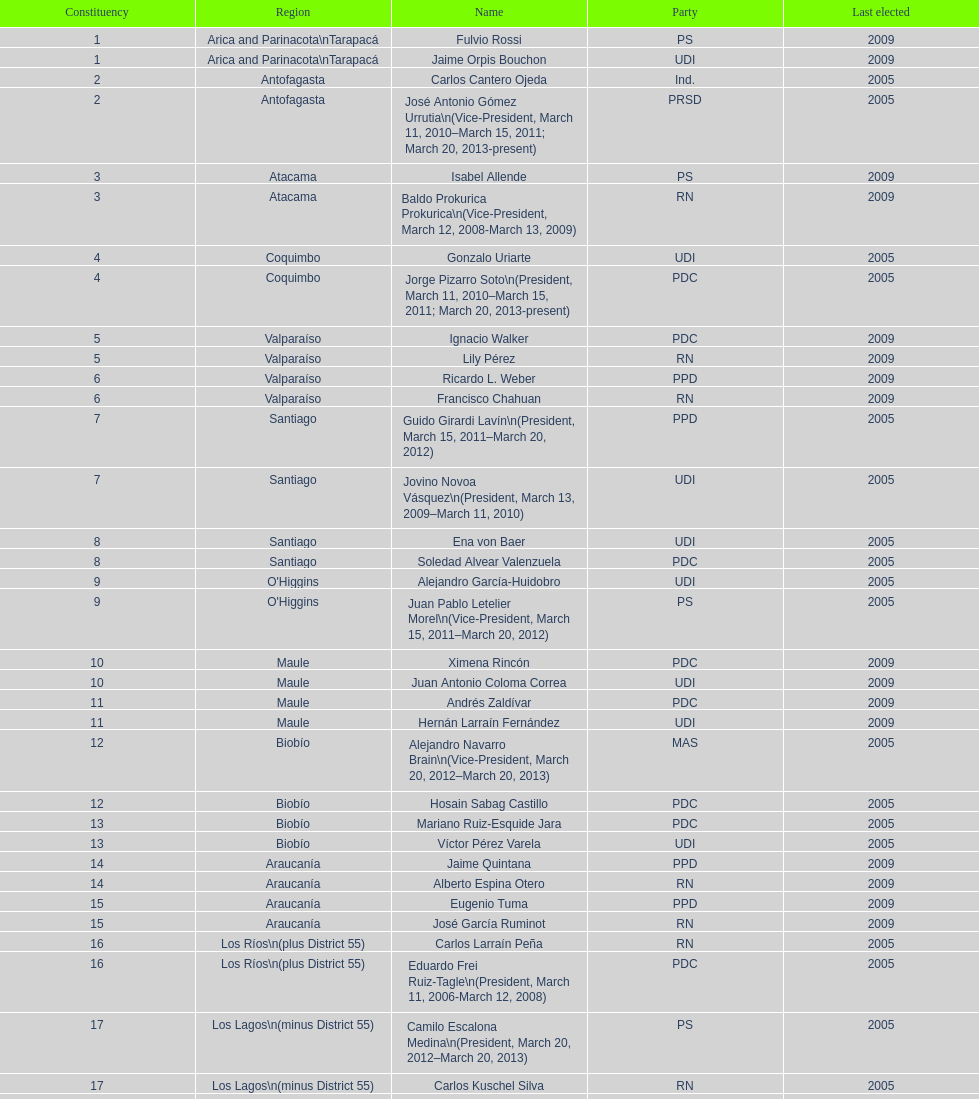How many total consituency are listed in the table? 19. 